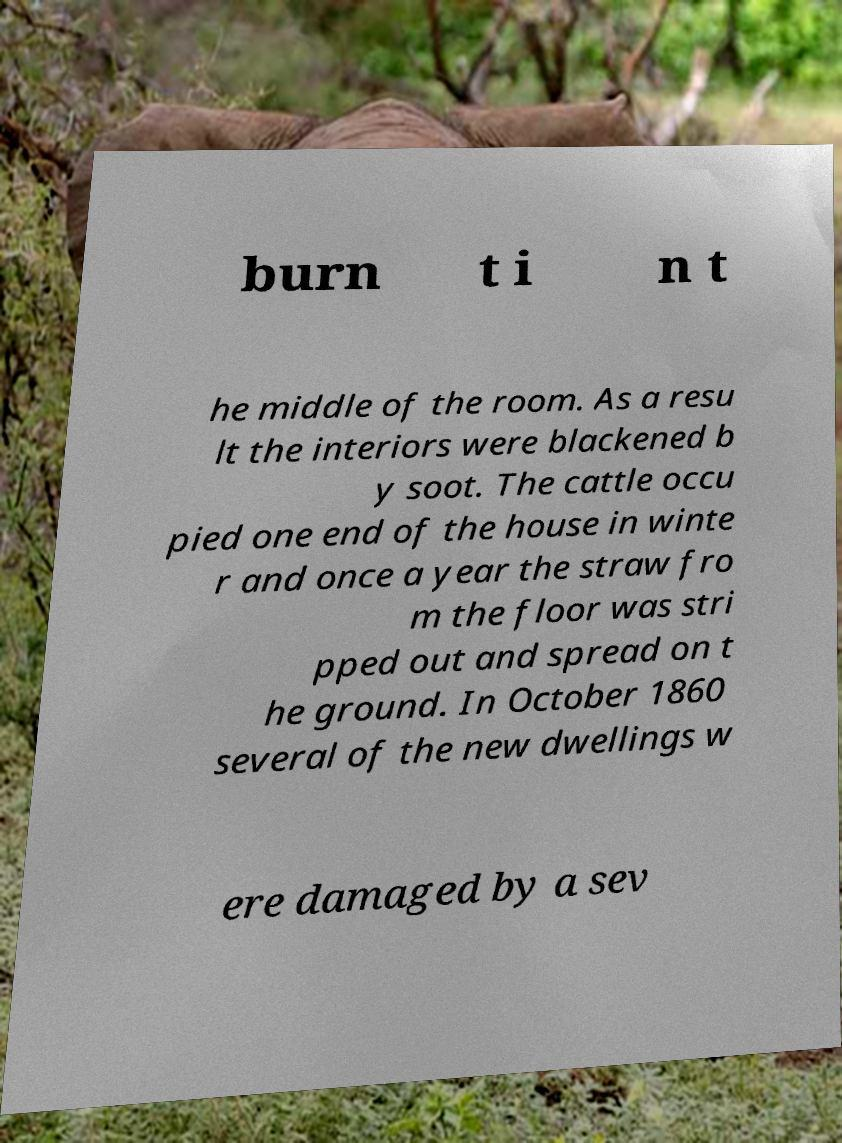Please read and relay the text visible in this image. What does it say? burn t i n t he middle of the room. As a resu lt the interiors were blackened b y soot. The cattle occu pied one end of the house in winte r and once a year the straw fro m the floor was stri pped out and spread on t he ground. In October 1860 several of the new dwellings w ere damaged by a sev 